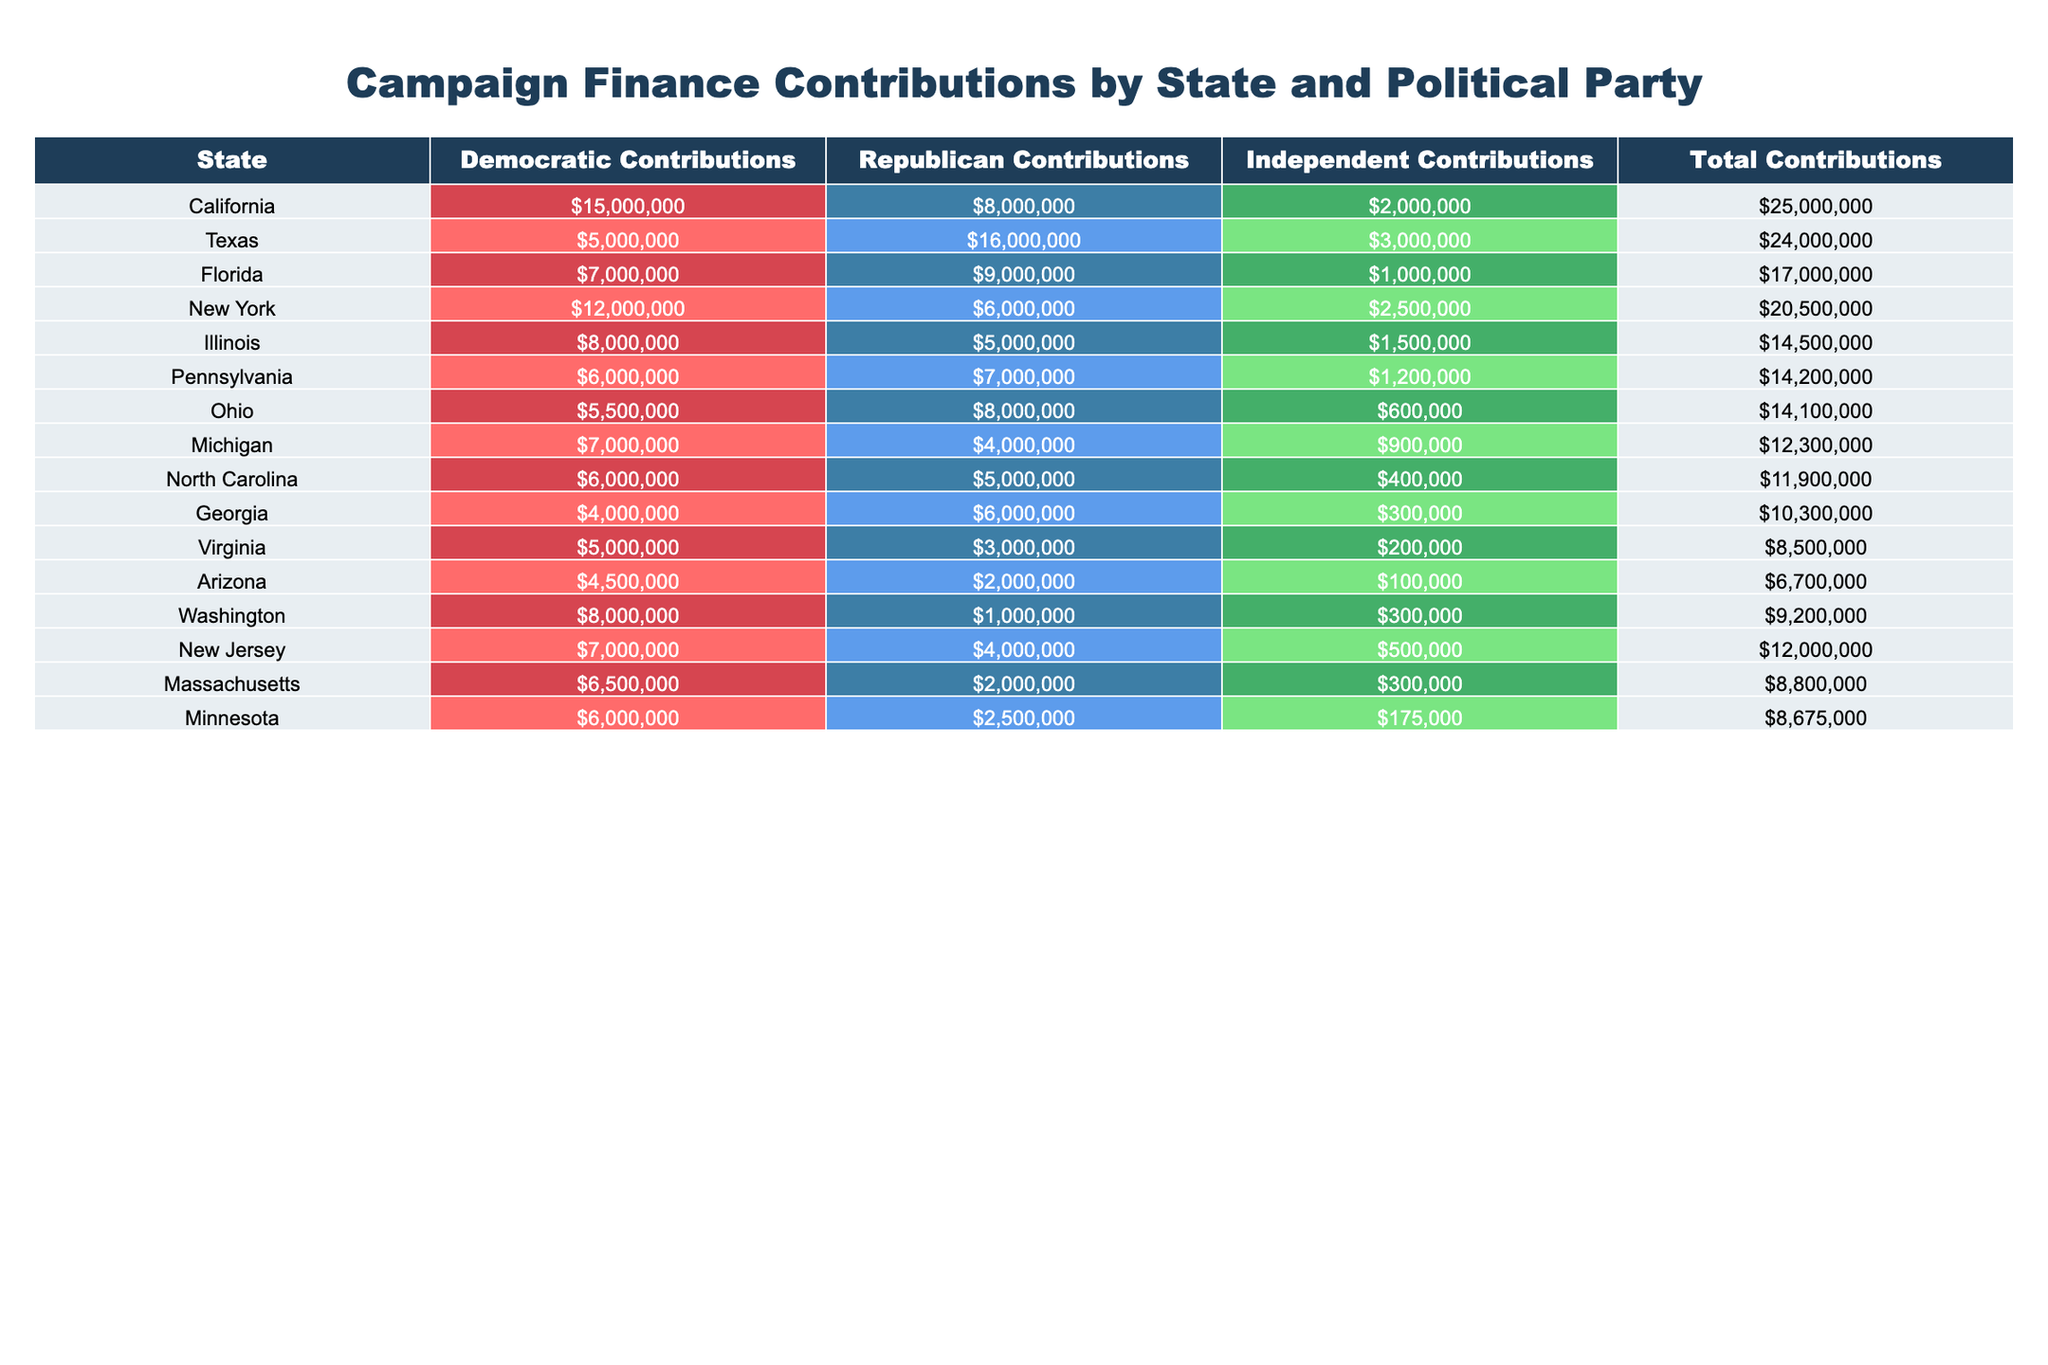What state has the highest Democratic contributions? By looking at the Democratic Contributions column, California has the highest value at $15,000,000.
Answer: California How much total contribution did Texas receive? The Total Contributions for Texas can be found directly in the table, which shows a value of $24,000,000.
Answer: $24,000,000 Which state received the least amount in Independent contributions? By examining the Independent Contributions column, Arizona has the lowest value at $100,000.
Answer: Arizona What is the average Republican contribution across all states? To find the average Republican contribution, sum all the contributions ($8,000,000 + $16,000,000 + $9,000,000 + ... + $2,000,000) to get $54,000,000, then divide by the number of states (15), which equals $3,600,000.
Answer: $3,600,000 Which political party received more than $10,000,000 in contributions in at least 5 states? Looking at the table, Democratic contributions in California, Texas, Florida, New York, and Illinois exceed $10,000,000. The Republican party has contributions over this threshold in Texas and Florida as well. Therefore, the Democratic party fits this condition.
Answer: Yes What percentage of Total Contributions in Florida came from Republican contributions? Florida's Total Contributions are $17,000,000, and Republican Contributions are $9,000,000. Therefore, the percentage is ($9,000,000 / $17,000,000) * 100 = 52.94%.
Answer: 52.94% Which state has the largest gap between Republican and Democratic contributions? First, calculate the gaps: For Texas, it's $16,000,000 - $5,000,000 = $11,000,000; for California, it's $15,000,000 - $8,000,000 = $7,000,000. The state with the largest gap is Texas.
Answer: Texas How many states received at least $8,000,000 in Independent contributions? Checking the Independent Contributions column, the states receiving at least $8,000,000 are California and New York, totaling 2 states.
Answer: 2 Does any state show a Democratic contribution lower than its Independent contribution? Comparing the values, Virginia shows Democratic contributions of $5,000,000 versus Independent contributions of $200,000. Therefore, no state has lower Democratic contributions than Independent contributions.
Answer: No Which state had the second highest total contributions? After comparing total contributions by state, Texas has the second highest total contribution at $24,000,000.
Answer: Texas 